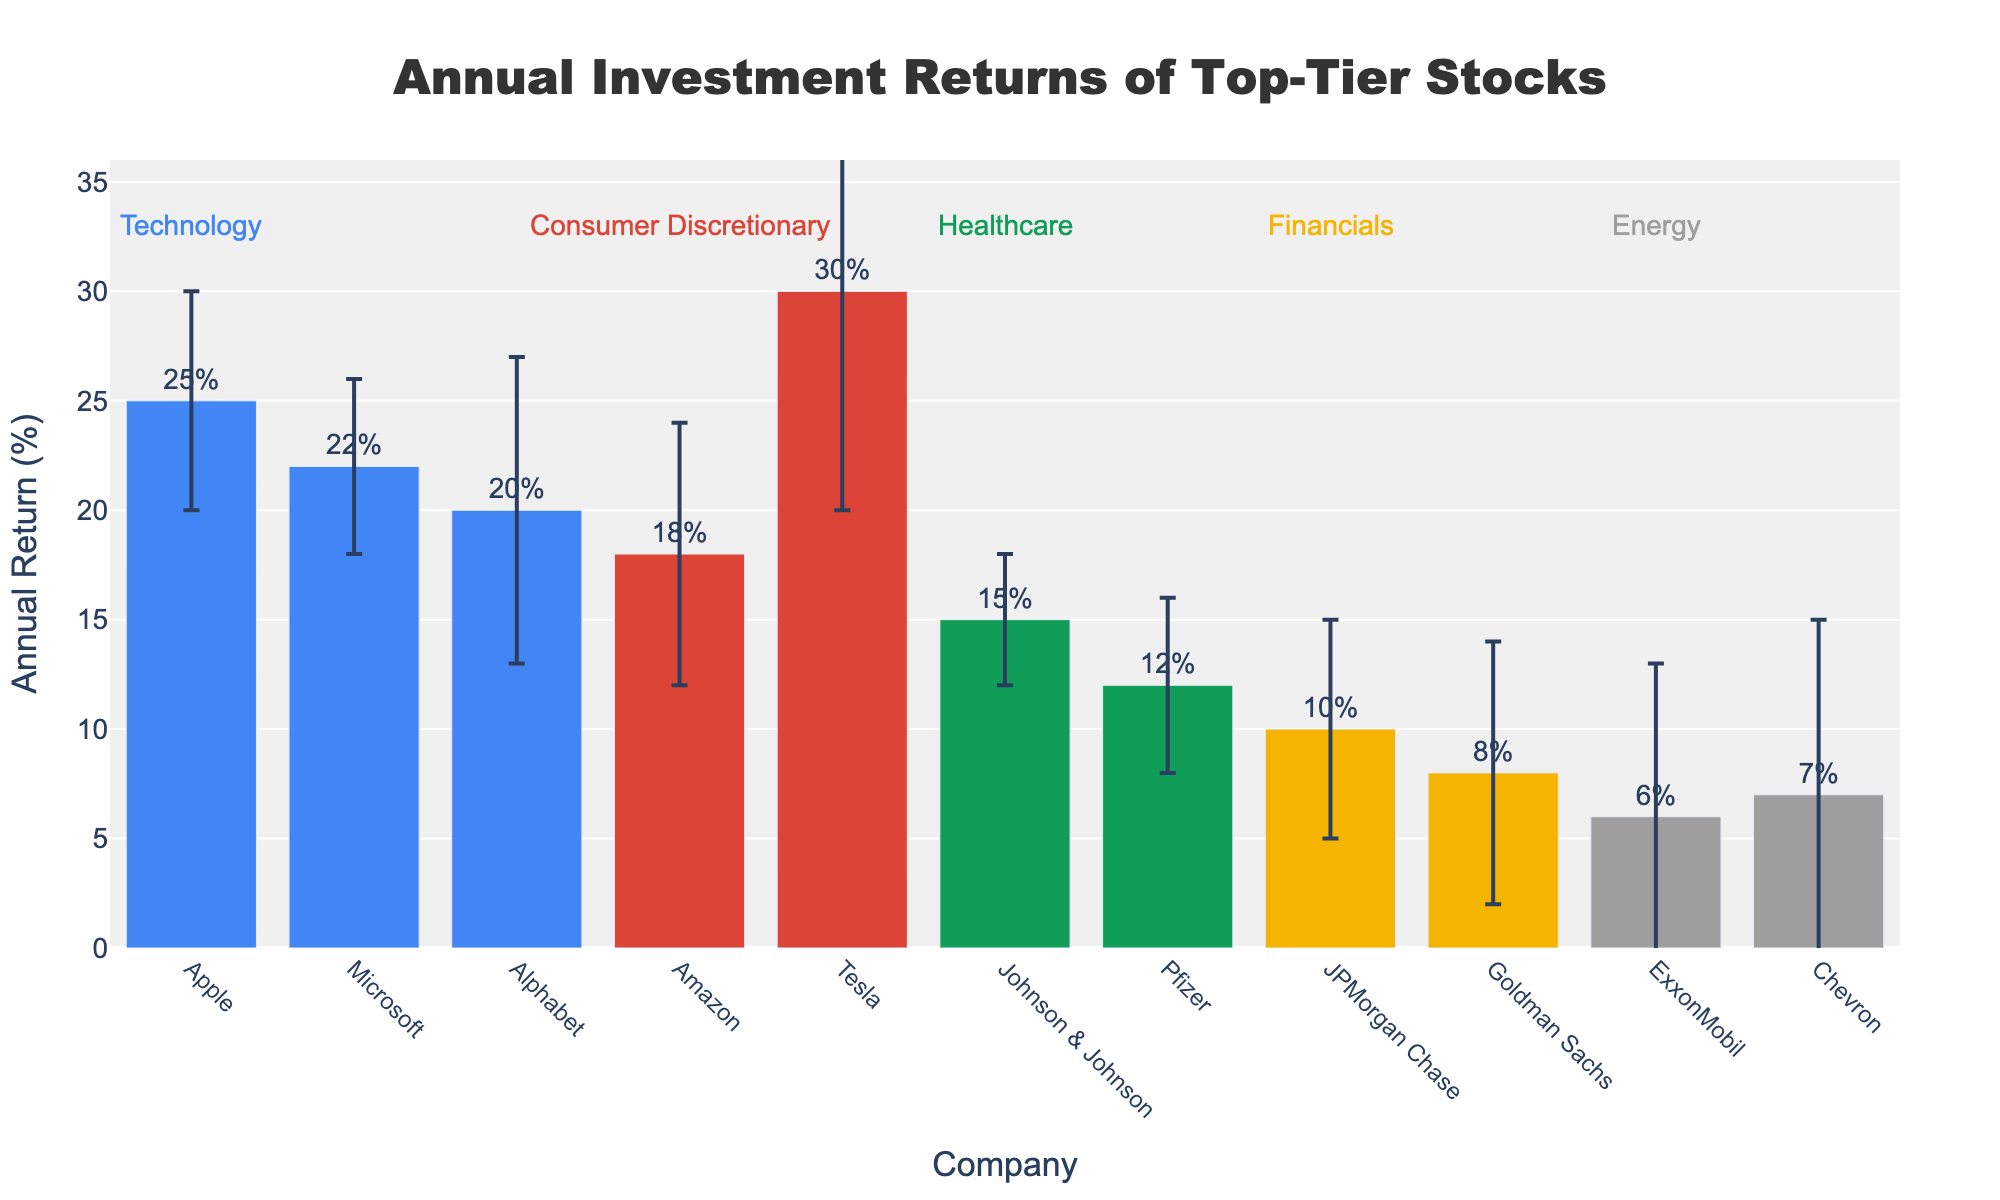what is the annual return of Tesla? Look at the bar representing Tesla and read the corresponding value on the y-axis. Tesla's bar is at 30%.
Answer: 30% Which sector has the highest average annual return? Calculate the average annual return for each sector, then compare these values. The sectors are Technology (22.33%), Consumer Discretionary (24%), Healthcare (13.5%), Financials (9%), and Energy (6.5%). Consumer Discretionary has the highest average annual return.
Answer: Consumer Discretionary Which company in the Healthcare sector has a higher annual return? Compare the annual returns of Johnson & Johnson and Pfizer. Johnson & Johnson has an annual return of 15%, while Pfizer has 12%.
Answer: Johnson & Johnson Which company has the largest standard deviation in its annual return? Look at the error bars and compare their lengths. Tesla has the largest standard deviation with 10%.
Answer: Tesla By how much does Microsoft's annual return exceed that of Goldman Sachs? Subtract Goldman Sachs' annual return (8%) from Microsoft's annual return (22%). 22% - 8% = 14%.
Answer: 14% What is the title of the chart? The title is positioned at the top of the chart and reads "Annual Investment Returns of Top-Tier Stocks".
Answer: Annual Investment Returns of Top-Tier Stocks What is the difference in annual return between the highest and lowest stocks? The highest annual return is Tesla (30%) and the lowest is ExxonMobil (6%). Subtract the lowest from the highest: 30% - 6% = 24%.
Answer: 24% Which sector appears first in the chart's x-axis arrangement? Identify the first company name on the x-axis and find its corresponding sector. Apple appears first, which is part of the Technology sector.
Answer: Technology 